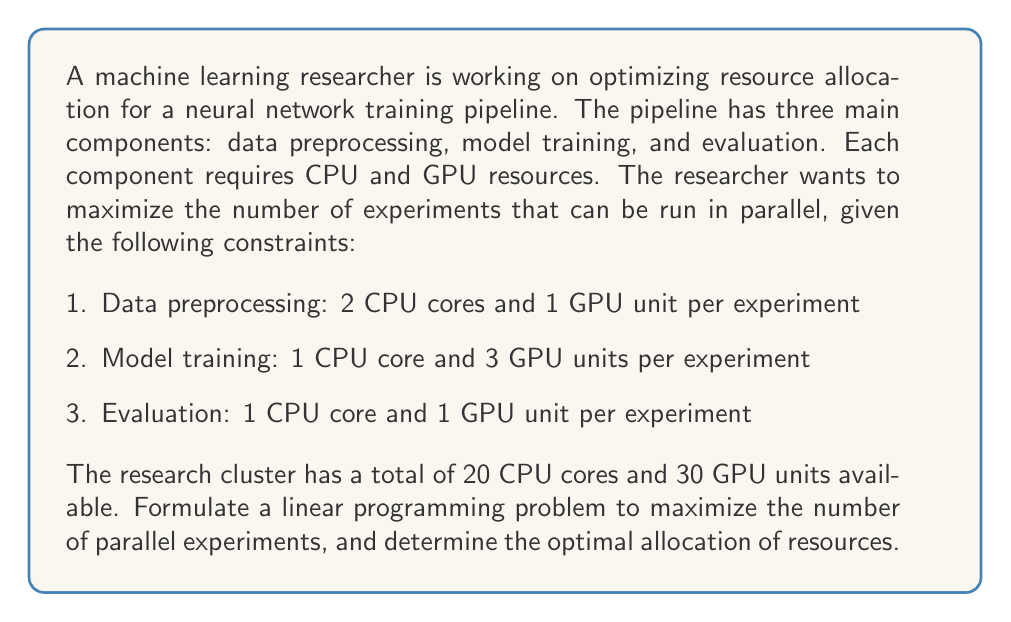Can you solve this math problem? Let's approach this step-by-step:

1. Define variables:
   Let $x$ be the number of experiments run in parallel.

2. Objective function:
   We want to maximize the number of experiments, so our objective function is:
   $$\text{Maximize } x$$

3. Constraints:
   a) CPU constraint:
      Each experiment requires $(2 + 1 + 1) = 4$ CPU cores
      Total CPU cores available = 20
      $$4x \leq 20$$

   b) GPU constraint:
      Each experiment requires $(1 + 3 + 1) = 5$ GPU units
      Total GPU units available = 30
      $$5x \leq 30$$

   c) Non-negativity constraint:
      $$x \geq 0$$

4. Linear Programming formulation:
   $$\begin{align*}
   \text{Maximize: } & x \\
   \text{Subject to: } & 4x \leq 20 \\
   & 5x \leq 30 \\
   & x \geq 0
   \end{align*}$$

5. Solving the LP problem:
   We can solve this by considering each constraint:
   a) From CPU constraint: $x \leq 20/4 = 5$
   b) From GPU constraint: $x \leq 30/5 = 6$

   The binding constraint is the CPU constraint, as it's more restrictive.

6. Optimal solution:
   The maximum value of $x$ that satisfies both constraints is 5.

Therefore, the optimal allocation is to run 5 experiments in parallel, which will use all 20 CPU cores and 25 out of 30 GPU units.
Answer: 5 parallel experiments 